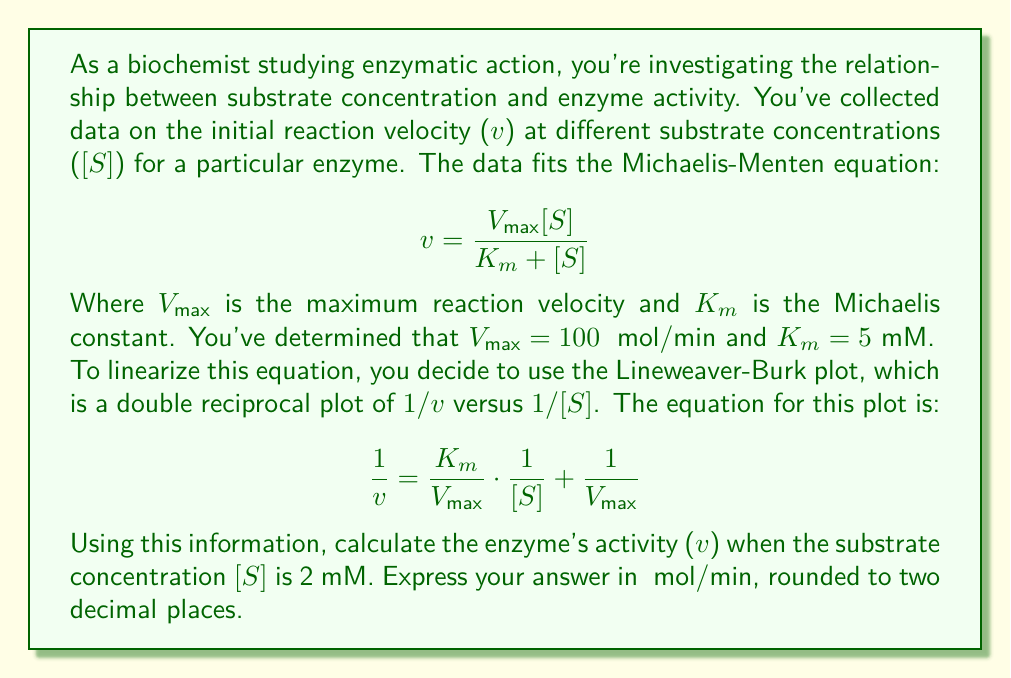Solve this math problem. To solve this problem, we'll follow these steps:

1) First, let's recall the Lineweaver-Burk equation:

   $$ \frac{1}{v} = \frac{K_m}{V_{max}} \cdot \frac{1}{[S]} + \frac{1}{V_{max}} $$

2) We're given that $V_{max} = 100$ μmol/min, $K_m = 5$ mM, and [S] = 2 mM.

3) Let's substitute these values into the equation:

   $$ \frac{1}{v} = \frac{5}{100} \cdot \frac{1}{2} + \frac{1}{100} $$

4) Simplify:
   
   $$ \frac{1}{v} = \frac{5}{200} + \frac{1}{100} = \frac{2.5}{100} + \frac{1}{100} = \frac{3.5}{100} $$

5) Now we have:

   $$ \frac{1}{v} = \frac{3.5}{100} $$

6) To find v, we need to take the reciprocal of both sides:

   $$ v = \frac{100}{3.5} $$

7) Calculate the final result:

   $$ v = 28.5714... \text{ μmol/min} $$

8) Rounding to two decimal places:

   $$ v \approx 28.57 \text{ μmol/min} $$
Answer: 28.57 μmol/min 